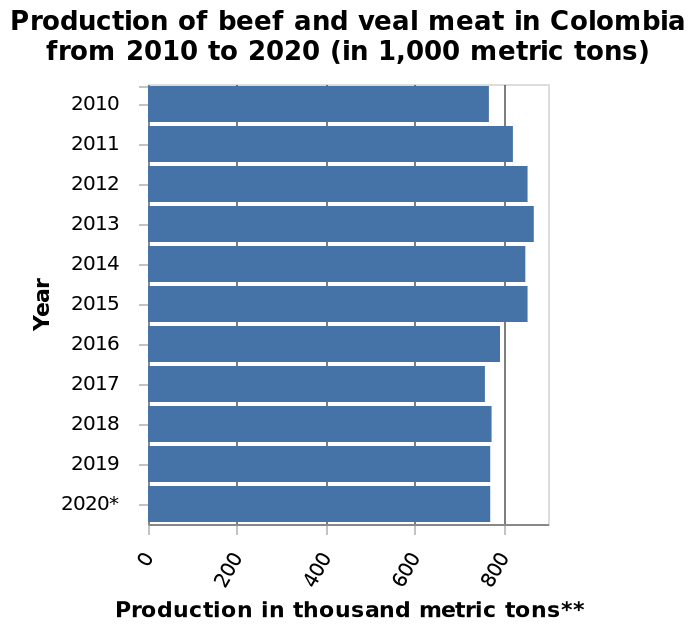<image>
What was the highest production level of beef and veal during the given timeframe? The highest production level reached was approximately 900 thousand metric tons. What is the starting year on the y-axis in the bar diagram? The starting year on the y-axis is 2010. 